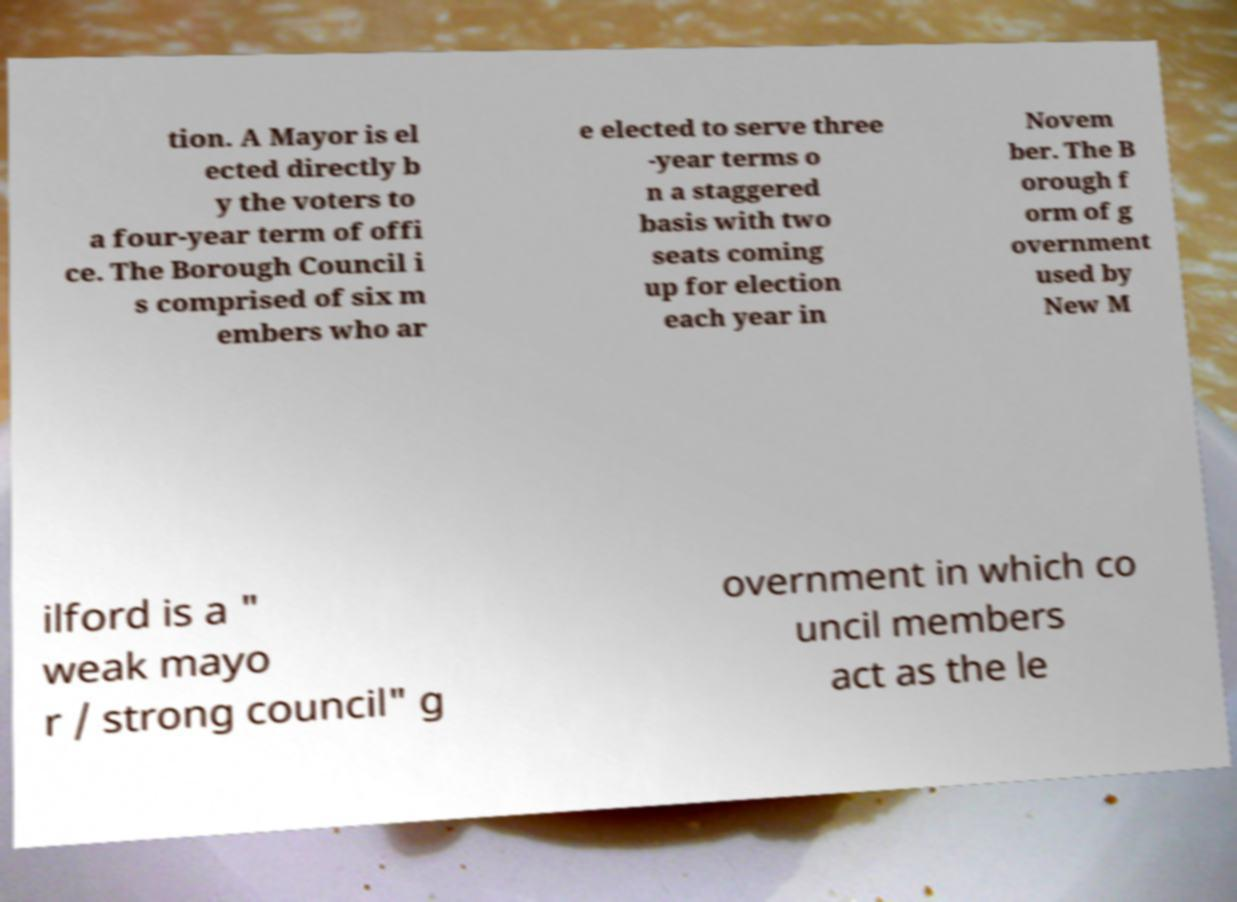Could you assist in decoding the text presented in this image and type it out clearly? tion. A Mayor is el ected directly b y the voters to a four-year term of offi ce. The Borough Council i s comprised of six m embers who ar e elected to serve three -year terms o n a staggered basis with two seats coming up for election each year in Novem ber. The B orough f orm of g overnment used by New M ilford is a " weak mayo r / strong council" g overnment in which co uncil members act as the le 